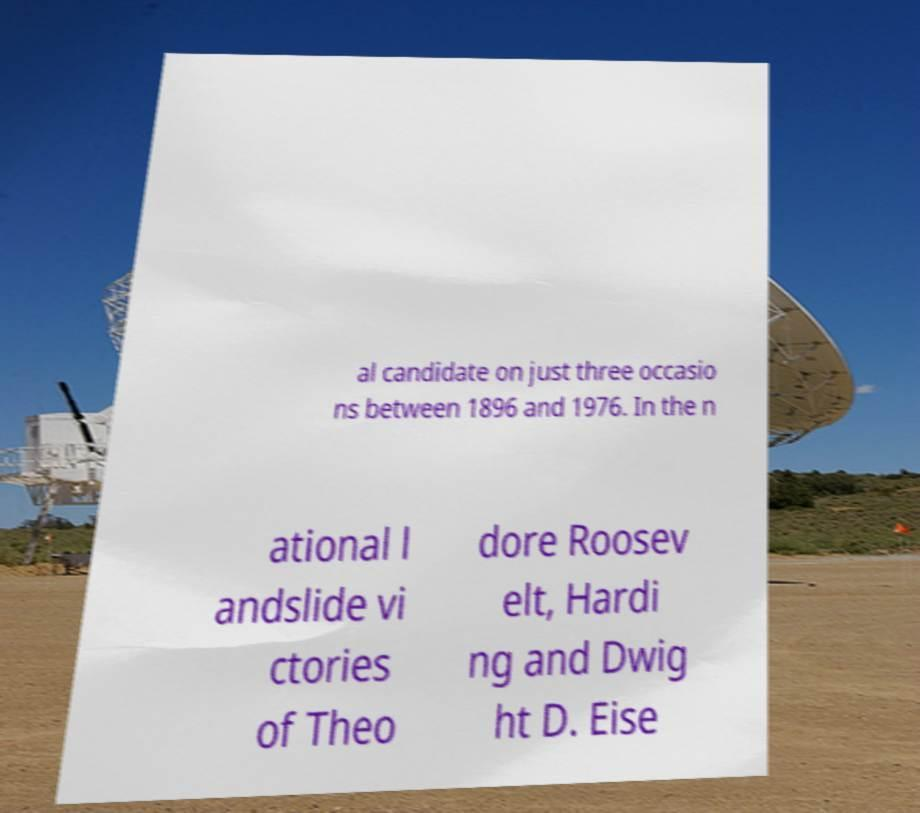What messages or text are displayed in this image? I need them in a readable, typed format. al candidate on just three occasio ns between 1896 and 1976. In the n ational l andslide vi ctories of Theo dore Roosev elt, Hardi ng and Dwig ht D. Eise 